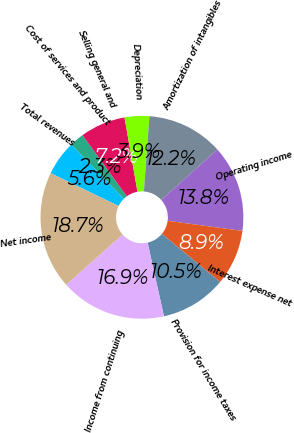Convert chart to OTSL. <chart><loc_0><loc_0><loc_500><loc_500><pie_chart><fcel>Total revenues<fcel>Cost of services and product<fcel>Selling general and<fcel>Depreciation<fcel>Amortization of intangibles<fcel>Operating income<fcel>Interest expense net<fcel>Provision for income taxes<fcel>Income from continuing<fcel>Net income<nl><fcel>5.58%<fcel>2.29%<fcel>7.22%<fcel>3.93%<fcel>12.16%<fcel>13.8%<fcel>8.87%<fcel>10.51%<fcel>16.91%<fcel>18.74%<nl></chart> 